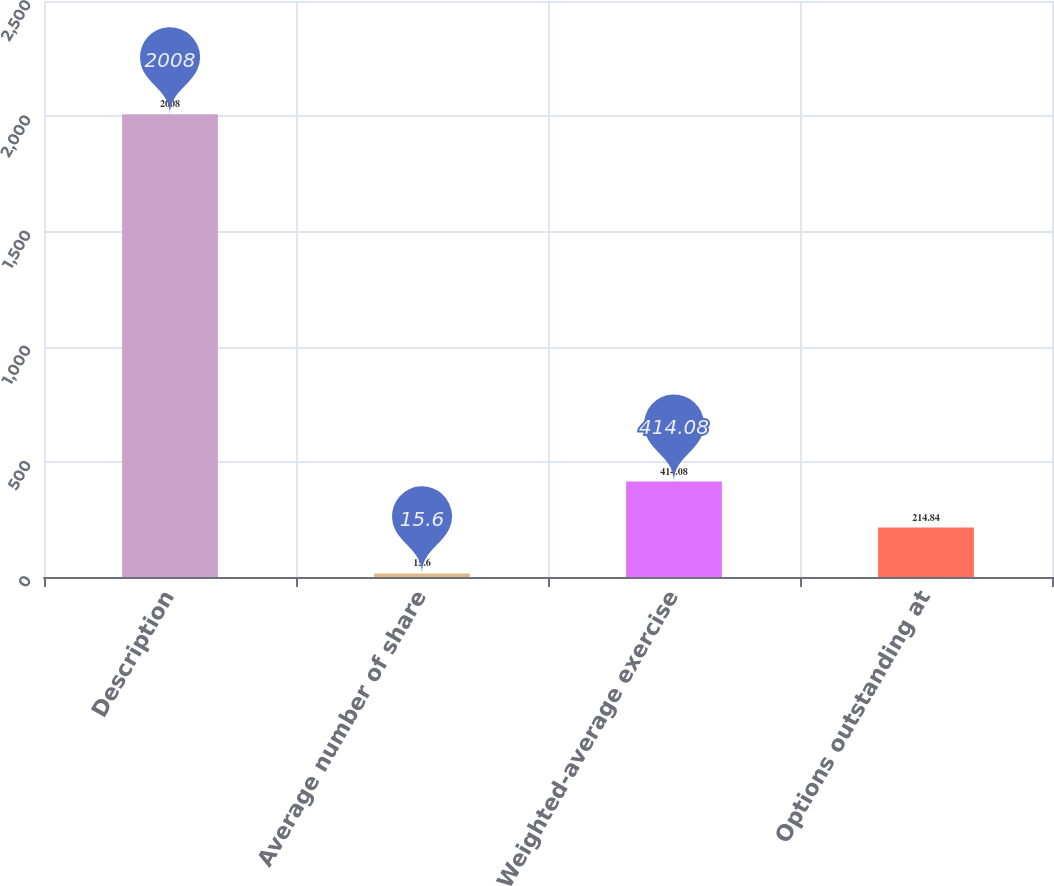<chart> <loc_0><loc_0><loc_500><loc_500><bar_chart><fcel>Description<fcel>Average number of share<fcel>Weighted-average exercise<fcel>Options outstanding at<nl><fcel>2008<fcel>15.6<fcel>414.08<fcel>214.84<nl></chart> 